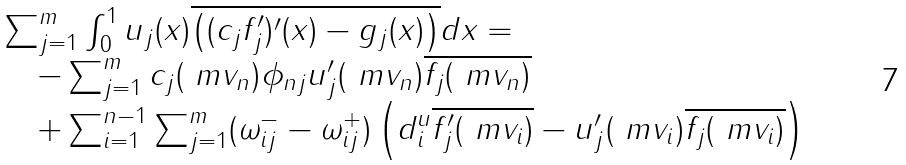Convert formula to latex. <formula><loc_0><loc_0><loc_500><loc_500>\begin{array} { r l } & \sum _ { j = 1 } ^ { m } \int _ { 0 } ^ { 1 } u _ { j } ( x ) \overline { \left ( ( c _ { j } f _ { j } ^ { \prime } ) ^ { \prime } ( x ) - g _ { j } ( x ) \right ) } d x = \\ & \quad - \sum _ { j = 1 } ^ { m } c _ { j } ( \ m v _ { n } ) \phi _ { n j } u ^ { \prime } _ { j } ( \ m v _ { n } ) \overline { f _ { j } ( \ m v _ { n } ) } \\ & \quad + \sum _ { i = 1 } ^ { n - 1 } \sum _ { j = 1 } ^ { m } ( \omega _ { i j } ^ { - } - \omega _ { i j } ^ { + } ) \left ( d ^ { u } _ { i } \overline { f ^ { \prime } _ { j } ( \ m v _ { i } ) } - u ^ { \prime } _ { j } ( \ m v _ { i } ) \overline { f _ { j } ( \ m v _ { i } ) } \right ) \end{array}</formula> 